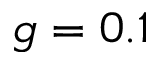Convert formula to latex. <formula><loc_0><loc_0><loc_500><loc_500>g = 0 . 1</formula> 